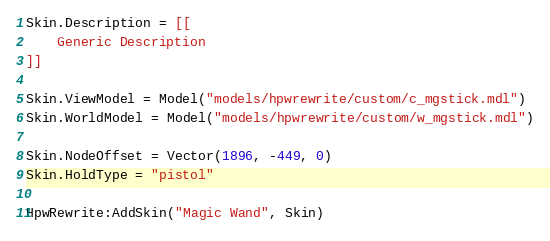<code> <loc_0><loc_0><loc_500><loc_500><_Lua_>Skin.Description = [[
	Generic Description
]]

Skin.ViewModel = Model("models/hpwrewrite/custom/c_mgstick.mdl")
Skin.WorldModel = Model("models/hpwrewrite/custom/w_mgstick.mdl")

Skin.NodeOffset = Vector(1896, -449, 0)
Skin.HoldType = "pistol"

HpwRewrite:AddSkin("Magic Wand", Skin)</code> 